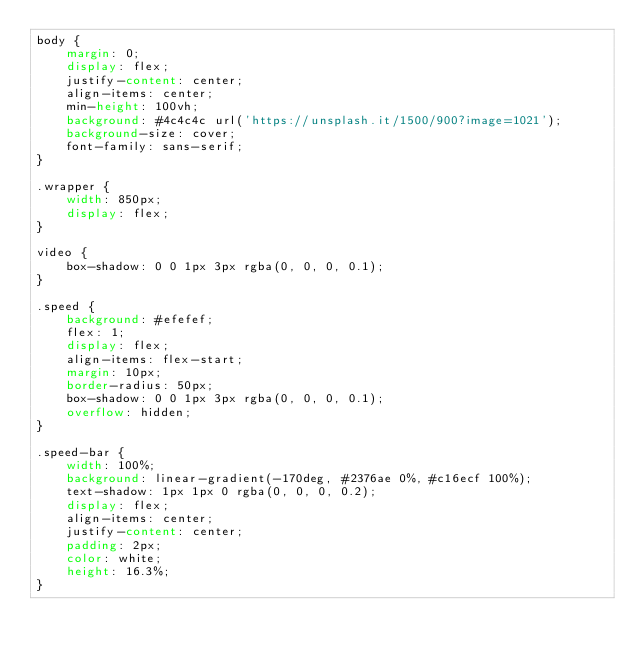<code> <loc_0><loc_0><loc_500><loc_500><_CSS_>body {
    margin: 0;
    display: flex;
    justify-content: center;
    align-items: center;
    min-height: 100vh;
    background: #4c4c4c url('https://unsplash.it/1500/900?image=1021');
    background-size: cover;
    font-family: sans-serif;
}

.wrapper {
    width: 850px;
    display: flex;
}

video {
    box-shadow: 0 0 1px 3px rgba(0, 0, 0, 0.1);
}

.speed {
    background: #efefef;
    flex: 1;
    display: flex;
    align-items: flex-start;
    margin: 10px;
    border-radius: 50px;
    box-shadow: 0 0 1px 3px rgba(0, 0, 0, 0.1);
    overflow: hidden;
}

.speed-bar {
    width: 100%;
    background: linear-gradient(-170deg, #2376ae 0%, #c16ecf 100%);
    text-shadow: 1px 1px 0 rgba(0, 0, 0, 0.2);
    display: flex;
    align-items: center;
    justify-content: center;
    padding: 2px;
    color: white;
    height: 16.3%;
}
</code> 